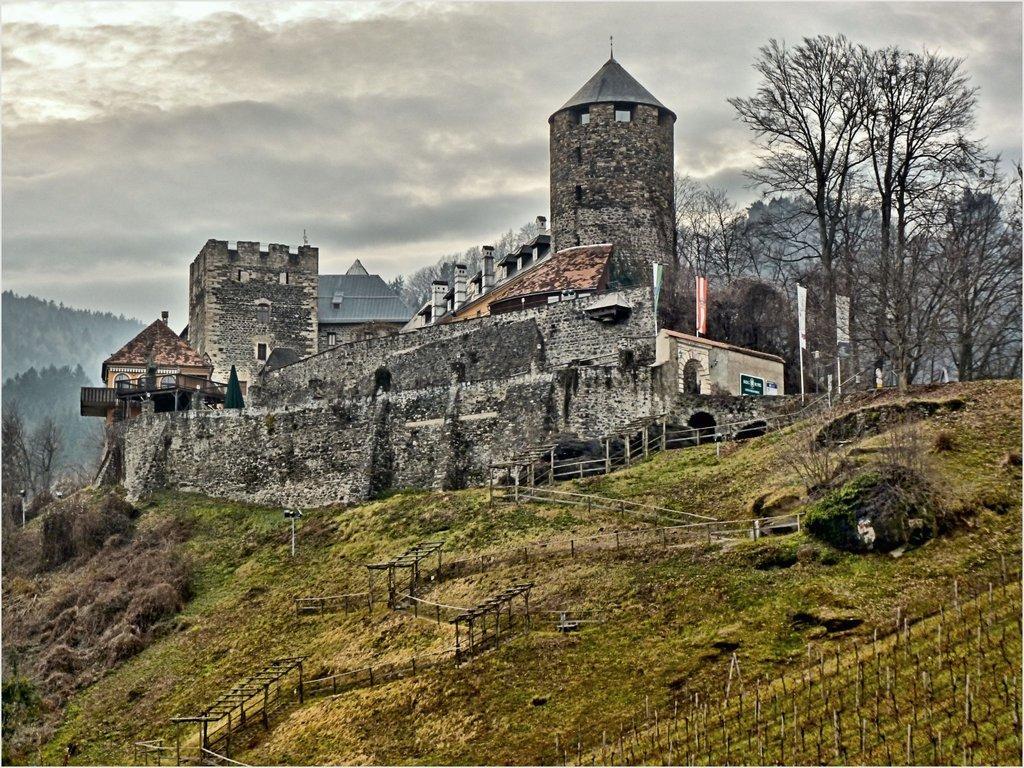Describe this image in one or two sentences. This is a building, which is on a hill. I think this is the pathway. I can see the trees and plants. This is the grass. These are the clouds in the sky. I can see the boards attached to the poles. 